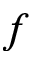<formula> <loc_0><loc_0><loc_500><loc_500>f</formula> 